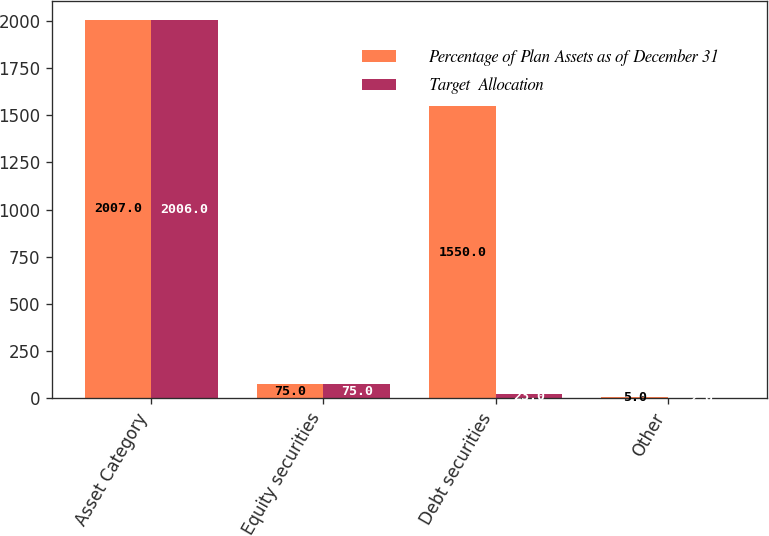Convert chart. <chart><loc_0><loc_0><loc_500><loc_500><stacked_bar_chart><ecel><fcel>Asset Category<fcel>Equity securities<fcel>Debt securities<fcel>Other<nl><fcel>Percentage of Plan Assets as of December 31<fcel>2007<fcel>75<fcel>1550<fcel>5<nl><fcel>Target  Allocation<fcel>2006<fcel>75<fcel>23<fcel>2<nl></chart> 